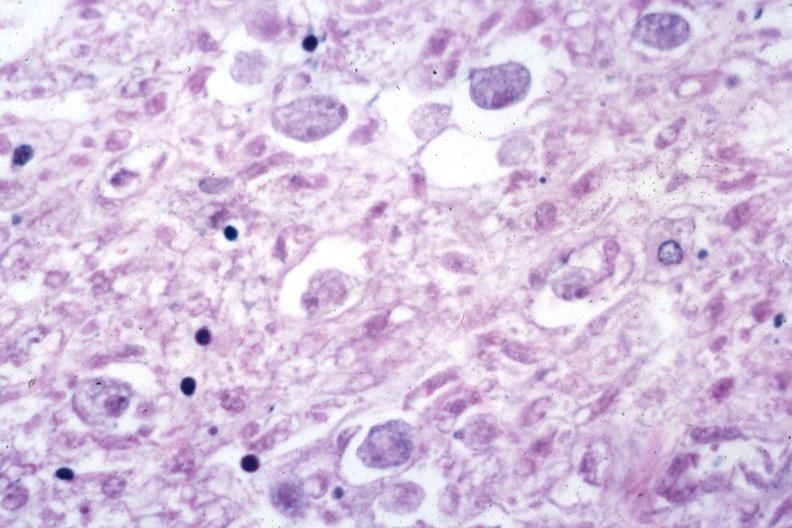s cervix duplication present?
Answer the question using a single word or phrase. No 